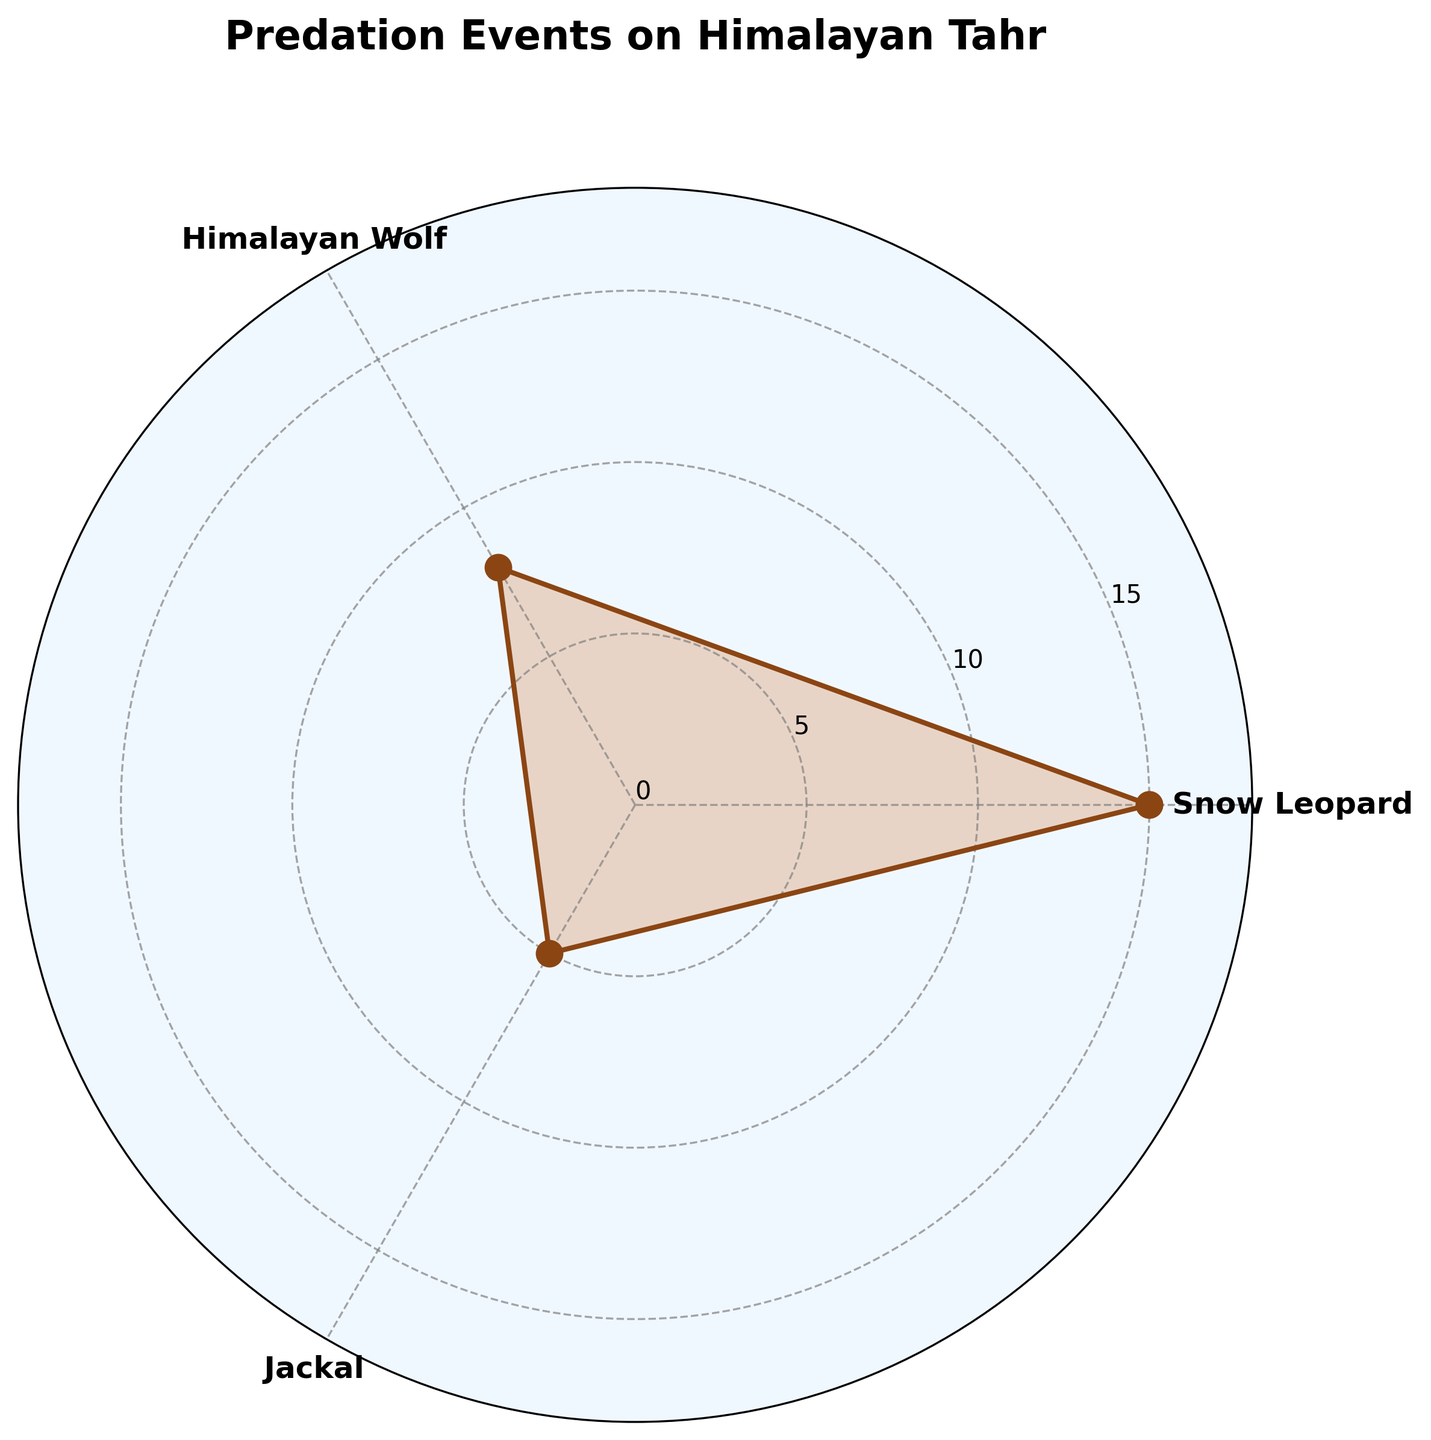What's the title of the figure? The title is typically displayed at the top of the figure in larger and bold font. It gives an overview of what the figure represents.
Answer: Predation Events on Himalayan Tahr How many predation events were reported for the Snow Leopard? Find the point connected to the "Snow Leopard" label on the angular axis. The length of the line associated with this label represents the number of events.
Answer: 15 What is the total number of predation events recorded for all predators? Sum up the individual predation events: Snow Leopard (15) + Himalayan Wolf (8) + Jackal (5). The closing value of the plot (15) is excluded as it repeats the first value.
Answer: 28 Which predator has the least number of predation events? Compare the values associated with each predator: Snow Leopard (15), Himalayan Wolf (8), Jackal (5).
Answer: Jackal How many more predation events were reported for the Snow Leopard compared to the Himalayan Wolf? Find the difference between the number of predation events for Snow Leopard (15) and Himalayan Wolf (8).
Answer: 7 Which predators have values closer to the mean number of predation events, and what is the mean? Calculate the mean (average) of the predation events and compare each predator's value to this mean. Mean = (15 + 8 + 5) / 3 = 28 / 3 ≈ 9.33. Himalayan Wolf (8) is closest to the mean.
Answer: Himalayan Wolf, 9.33 Describe the color scheme used for the visual representation in the plot The line plot and markers use a brownish color ('#8B4513'), and the filled area has a lighter, orange-brown color ('#D2691E'). The plot background is light blue ('#F0F8FF').
Answer: Brown, Orange-brown, Light Blue What is the maximum value on the y-axis grid? Noting the y-axis grid values labeled on the plot, the highest value given specifies the upper limit.
Answer: 20 Considering the plot’s symmetical layout, which data representation would change if an additional predator with 10 events were added? Adding another predator would increase the number of data points, causing the angles to re-distribute and accommodating an extra angle slice. It would also adjust the bounding circle depicting data distribution.
Answer: Distribution angles and bounding circle 